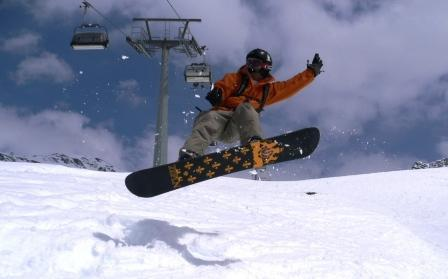What use would sitting in the seats have?

Choices:
A) up/downhill transport
B) avoiding sun
C) avoiding rain
D) dining up/downhill transport 